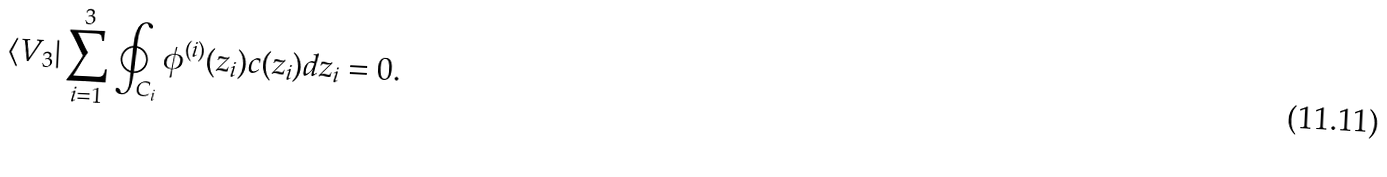<formula> <loc_0><loc_0><loc_500><loc_500>\langle V _ { 3 } | \sum _ { i = 1 } ^ { 3 } \oint _ { C _ { i } } \phi ^ { ( i ) } ( z _ { i } ) c ( z _ { i } ) d z _ { i } = 0 .</formula> 